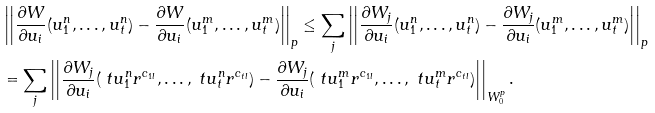<formula> <loc_0><loc_0><loc_500><loc_500>& \left | \left | \frac { \partial W } { \partial u _ { i } } ( u ^ { n } _ { 1 } , \dots , u ^ { n } _ { t } ) - \frac { \partial W } { \partial u _ { i } } ( u ^ { m } _ { 1 } , \dots , u ^ { m } _ { t } ) \right | \right | _ { p } \leq \sum _ { j } \left | \left | \frac { \partial W _ { j } } { \partial u _ { i } } ( u ^ { n } _ { 1 } , \dots , u ^ { n } _ { t } ) - \frac { \partial W _ { j } } { \partial u _ { i } } ( u ^ { m } _ { 1 } , \dots , u ^ { m } _ { t } ) \right | \right | _ { p } \\ & = \sum _ { j } \left | \left | \frac { \partial W _ { j } } { \partial u _ { i } } ( \ t u ^ { n } _ { 1 } r ^ { c _ { 1 l } } , \dots , \ t u ^ { n } _ { t } r ^ { c _ { t l } } ) - \frac { \partial W _ { j } } { \partial u _ { i } } ( \ t u ^ { m } _ { 1 } r ^ { c _ { 1 l } } , \dots , \ t u ^ { m } _ { t } r ^ { c _ { t l } } ) \right | \right | _ { W ^ { p } _ { 0 } } .</formula> 